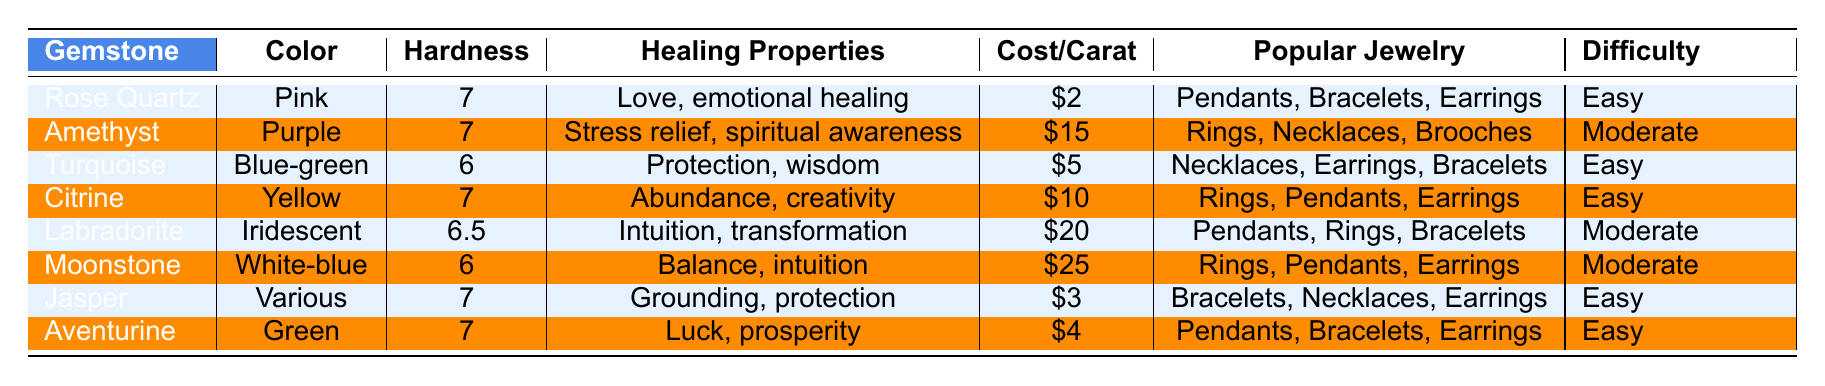What gemstone has the highest cost per carat? The table lists the cost per carat for each gemstone. The highest value is for Moonstone, which is $25 per carat.
Answer: Moonstone Which gemstones are easy to work with? The table indicates the difficulty to work with for each gemstone. Easy difficulty is listed for Rose Quartz, Turquoise, Citrine, Jasper, and Aventurine.
Answer: Rose Quartz, Turquoise, Citrine, Jasper, Aventurine What is the healing property of Labradorite? The table shows the healing properties of each gemstone. Labradorite is associated with intuition and transformation.
Answer: Intuition, transformation How many gemstones have a hardness of 7? The hardness ratings are provided in the table. The gemstones with a hardness of 7 are Rose Quartz, Amethyst, Citrine, Jasper, and Aventurine. In total, there are five gemstones.
Answer: 5 Which gemstone is the most difficult to work with? The table indicates the difficulty to work with each gemstone. The only moderate difficulty gemstones are Amethyst, Labradorite, and Moonstone.
Answer: Amethyst, Labradorite, Moonstone What is the average cost per carat of all gemstones listed? To find the average cost, we first add the cost of each gemstone ($2 + $15 + $5 + $10 + $20 + $25 + $3 + $4 = $84). Then divide by 8 (the number of gemstones), giving us $84 / 8 = $10.50.
Answer: 10.50 Which gemstones are suitable for rings? The table shows that the gemstones suitable for rings are Amethyst, Citrine, Labradorite, Moonstone, and Jasper.
Answer: Amethyst, Citrine, Labradorite, Moonstone, Jasper What color is Aventurine? The table states that the color of Aventurine is green.
Answer: Green Are there any gemstones with the same hardness? The hardness ratings reveal that Rose Quartz, Amethyst, Citrine, and Aventurine all have a hardness of 7. This confirms that there are gemstones with the same hardness.
Answer: Yes Which gemstone has the healing property of "Luck"? According to the table, Aventurine has the healing property associated with luck and prosperity.
Answer: Aventurine 